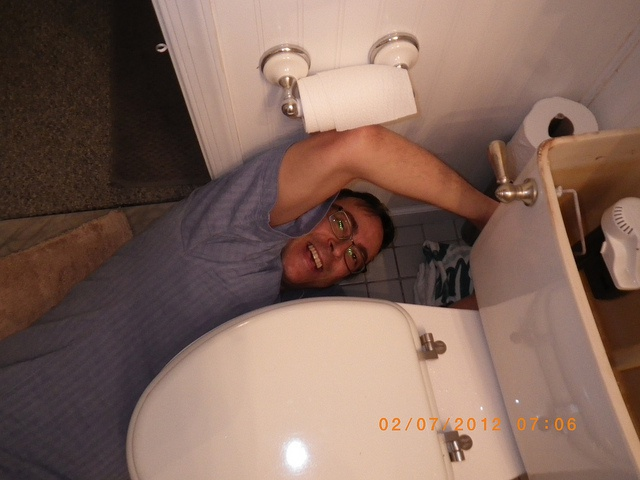Describe the objects in this image and their specific colors. I can see toilet in black, gray, tan, and darkgray tones and people in black, maroon, and gray tones in this image. 